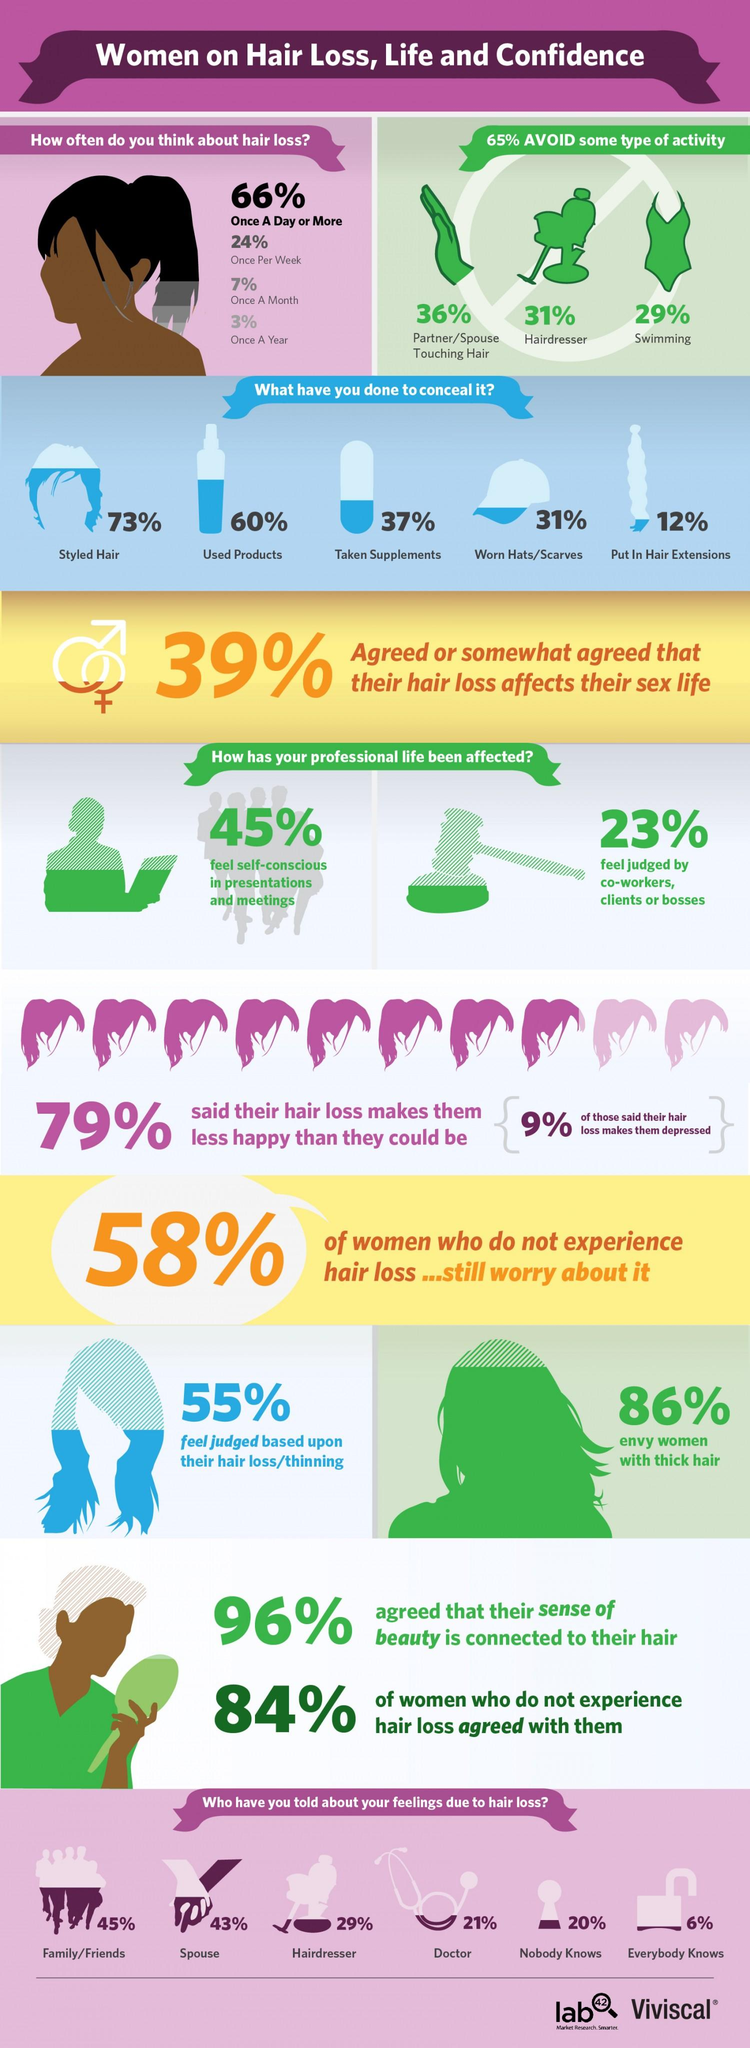Outline some significant characteristics in this image. According to the given information, 10% of people think about hair loss once a month and once a year, taken together. It is estimated that approximately 90% of individuals think about hair loss at least once per week, and approximately 90% of individuals also think about hair loss at least once per day, taken together. In total, 60% of people avoid hairdressers and swimming. According to a recent study, only 9% of women experience depression due to hair loss. According to a survey, 14% of people are not jealous of women with thick hair. 